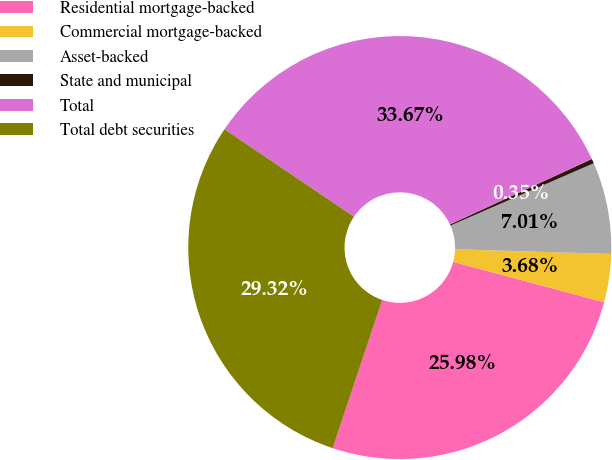<chart> <loc_0><loc_0><loc_500><loc_500><pie_chart><fcel>Residential mortgage-backed<fcel>Commercial mortgage-backed<fcel>Asset-backed<fcel>State and municipal<fcel>Total<fcel>Total debt securities<nl><fcel>25.98%<fcel>3.68%<fcel>7.01%<fcel>0.35%<fcel>33.67%<fcel>29.32%<nl></chart> 